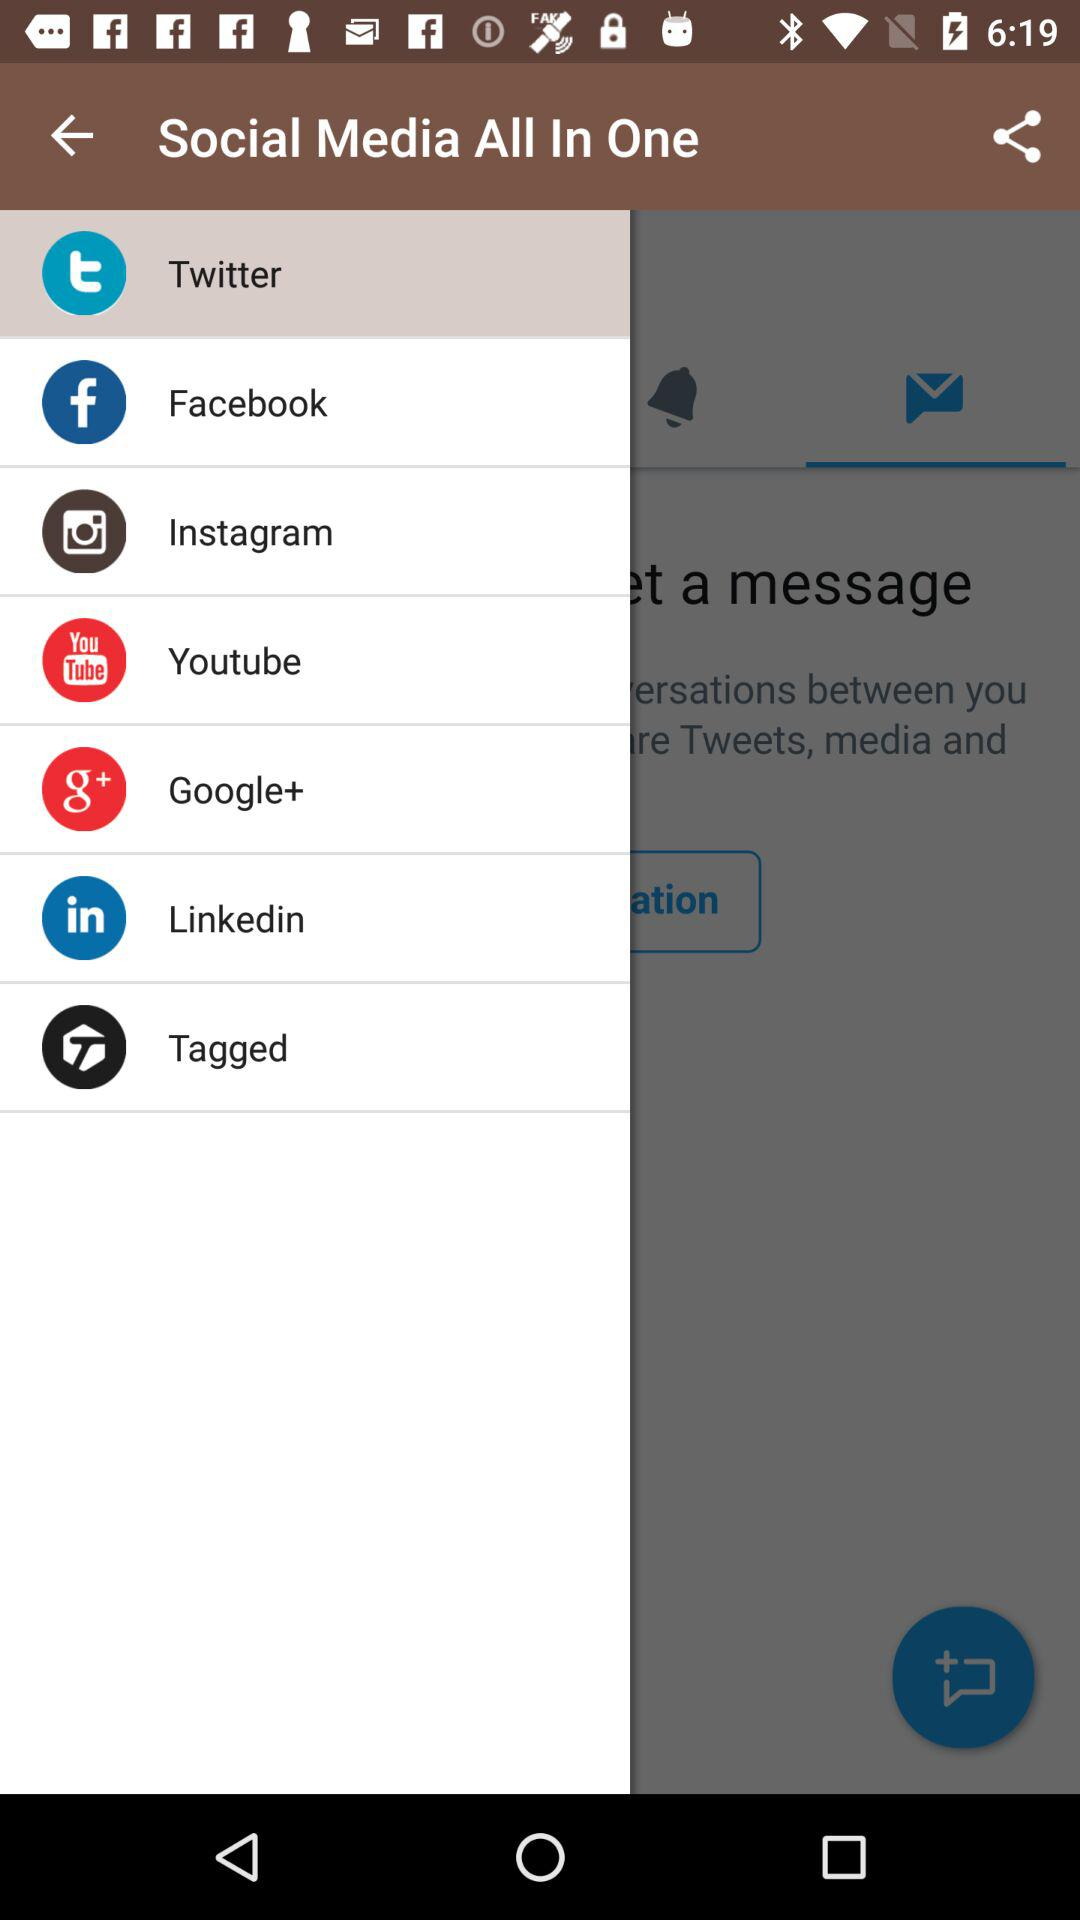What tab is selected? The selected tab is "Twitter". 